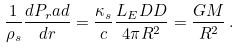<formula> <loc_0><loc_0><loc_500><loc_500>\frac { 1 } { \rho _ { s } } \frac { d P _ { r } a d } { d r } = \frac { \kappa _ { s } } { c } \frac { L _ { E } D D } { 4 \pi R ^ { 2 } } = \frac { G M } { R ^ { 2 } } \, .</formula> 